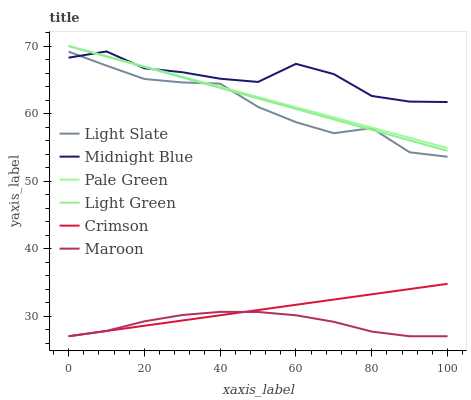Does Light Slate have the minimum area under the curve?
Answer yes or no. No. Does Light Slate have the maximum area under the curve?
Answer yes or no. No. Is Light Slate the smoothest?
Answer yes or no. No. Is Light Slate the roughest?
Answer yes or no. No. Does Light Slate have the lowest value?
Answer yes or no. No. Does Light Slate have the highest value?
Answer yes or no. No. Is Maroon less than Light Slate?
Answer yes or no. Yes. Is Pale Green greater than Crimson?
Answer yes or no. Yes. Does Maroon intersect Light Slate?
Answer yes or no. No. 